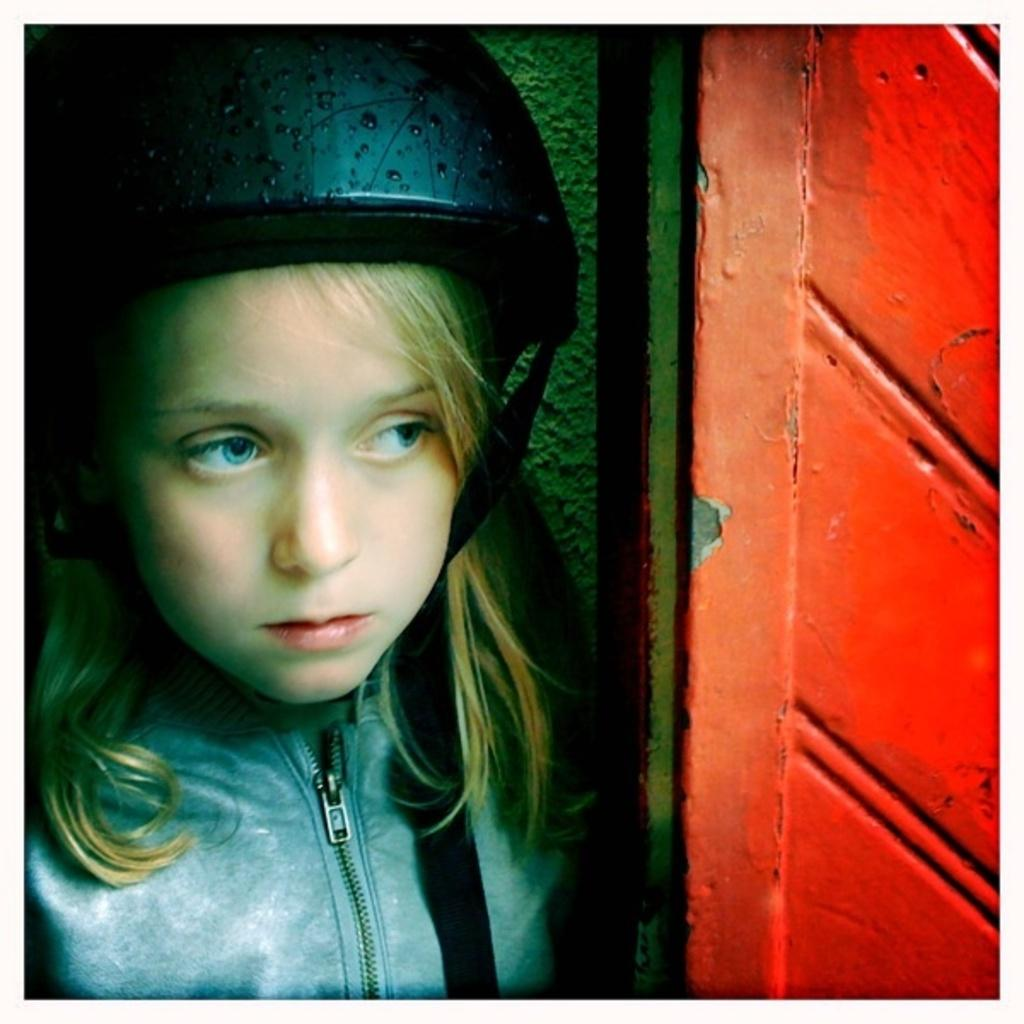Who is present in the picture? There is a girl in the picture. What is the girl wearing on her head? The girl is wearing a helmet. What color is the wall in the background of the picture? The wall in the background of the picture is green. Can you see any mountains in the background of the picture? There are no mountains visible in the background of the picture; it features a green wall. What action is the girl performing in the picture? The provided facts do not mention any specific action the girl is performing in the picture. 